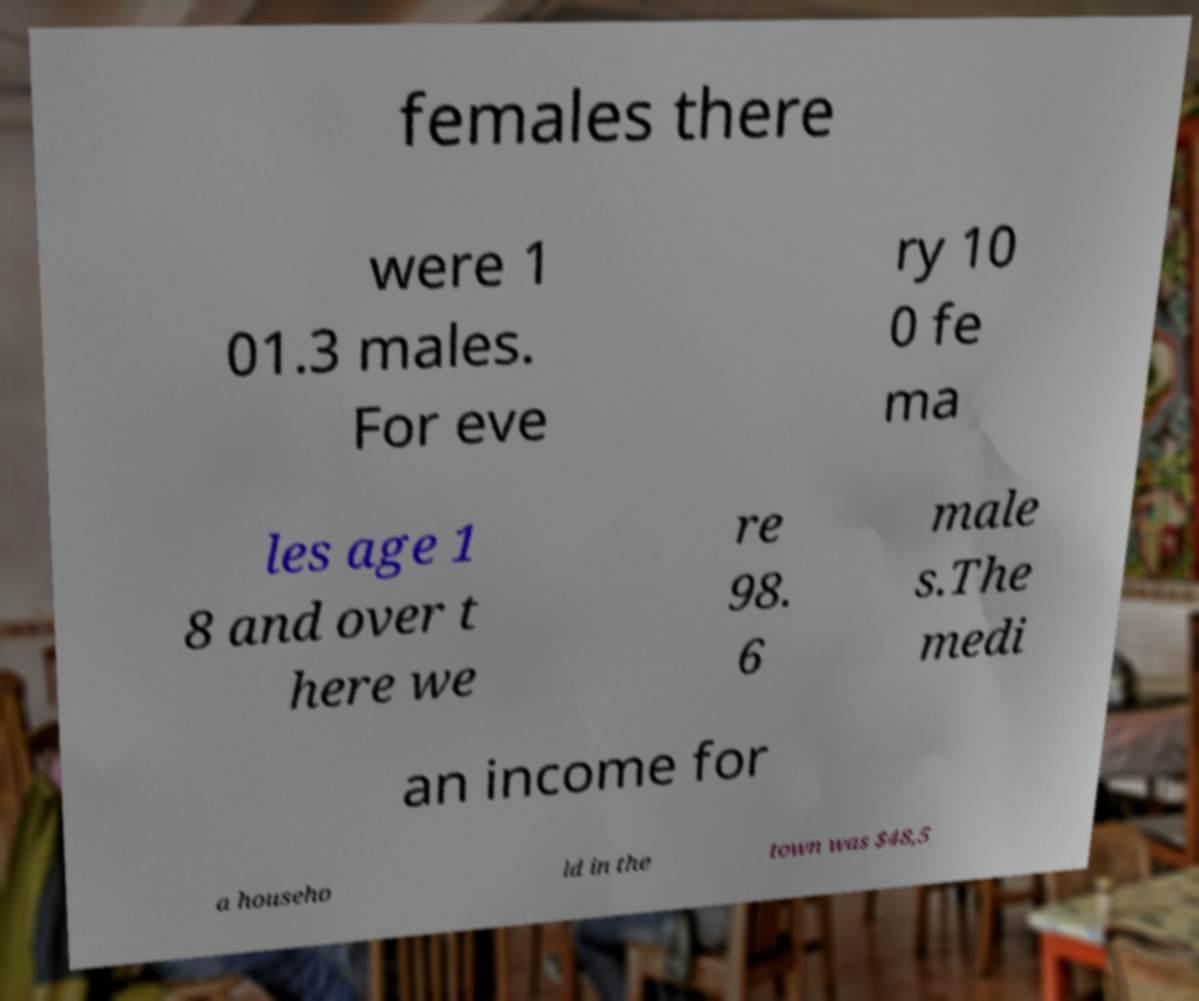Please read and relay the text visible in this image. What does it say? females there were 1 01.3 males. For eve ry 10 0 fe ma les age 1 8 and over t here we re 98. 6 male s.The medi an income for a househo ld in the town was $48,5 